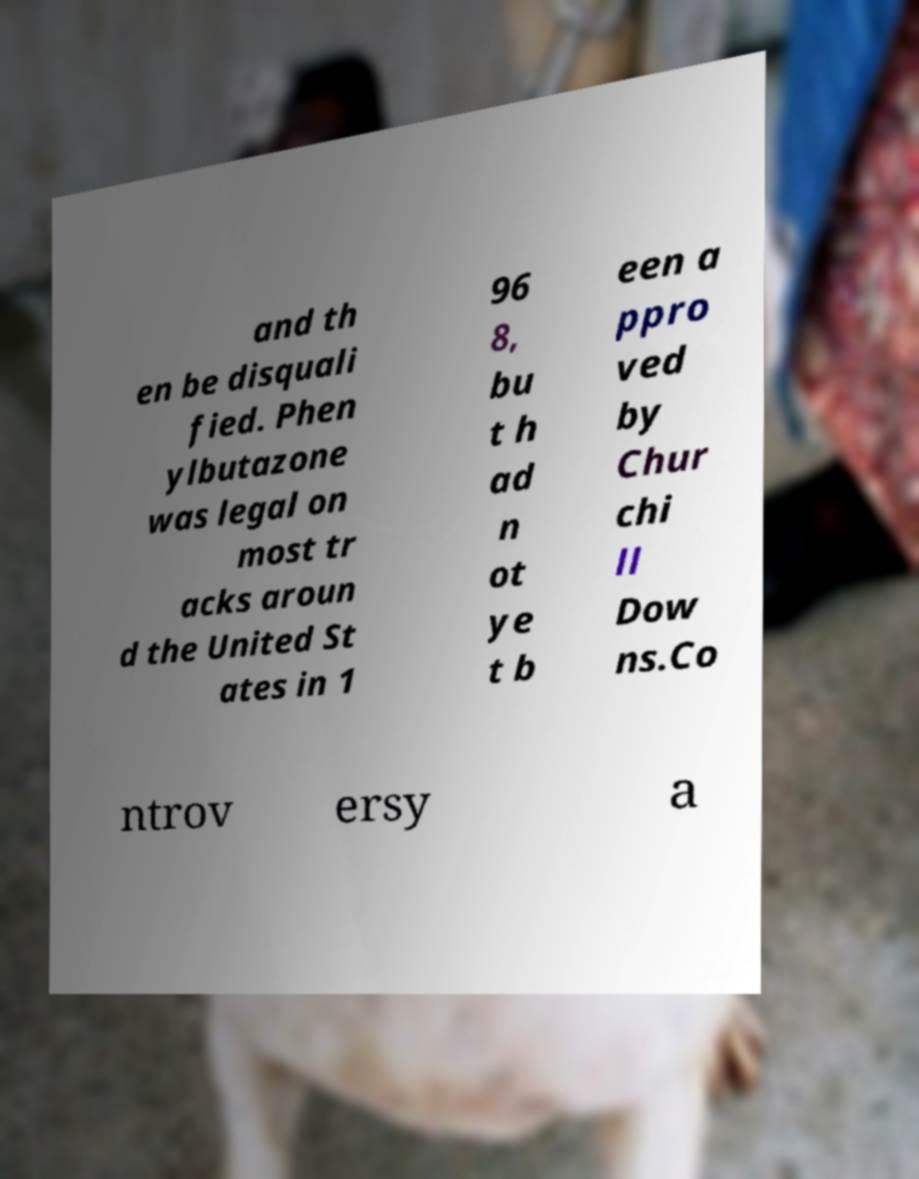For documentation purposes, I need the text within this image transcribed. Could you provide that? and th en be disquali fied. Phen ylbutazone was legal on most tr acks aroun d the United St ates in 1 96 8, bu t h ad n ot ye t b een a ppro ved by Chur chi ll Dow ns.Co ntrov ersy a 